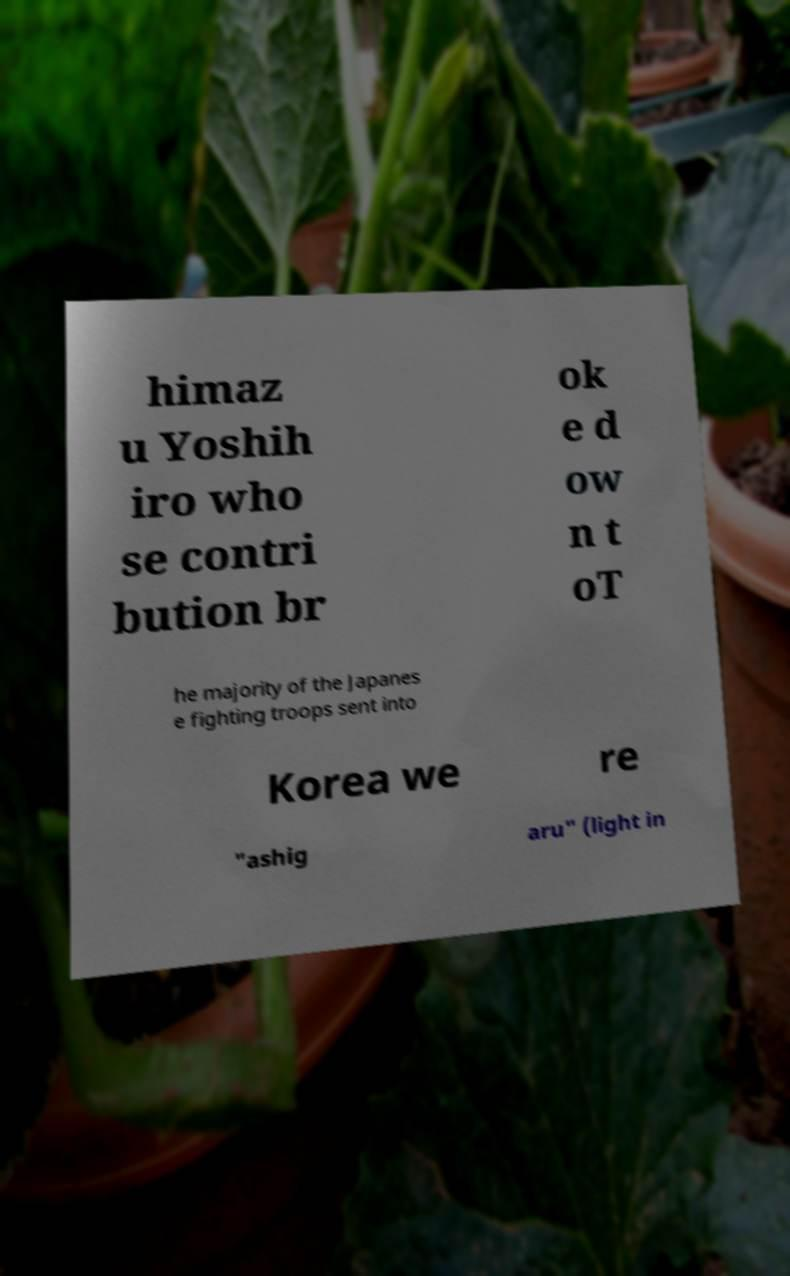Please identify and transcribe the text found in this image. himaz u Yoshih iro who se contri bution br ok e d ow n t oT he majority of the Japanes e fighting troops sent into Korea we re "ashig aru" (light in 